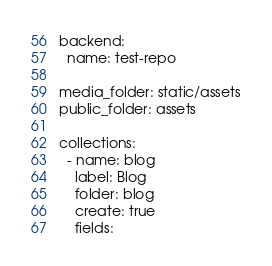Convert code to text. <code><loc_0><loc_0><loc_500><loc_500><_YAML_>backend:
  name: test-repo
 
media_folder: static/assets
public_folder: assets
 
collections:
  - name: blog
    label: Blog
    folder: blog
    create: true
    fields:</code> 